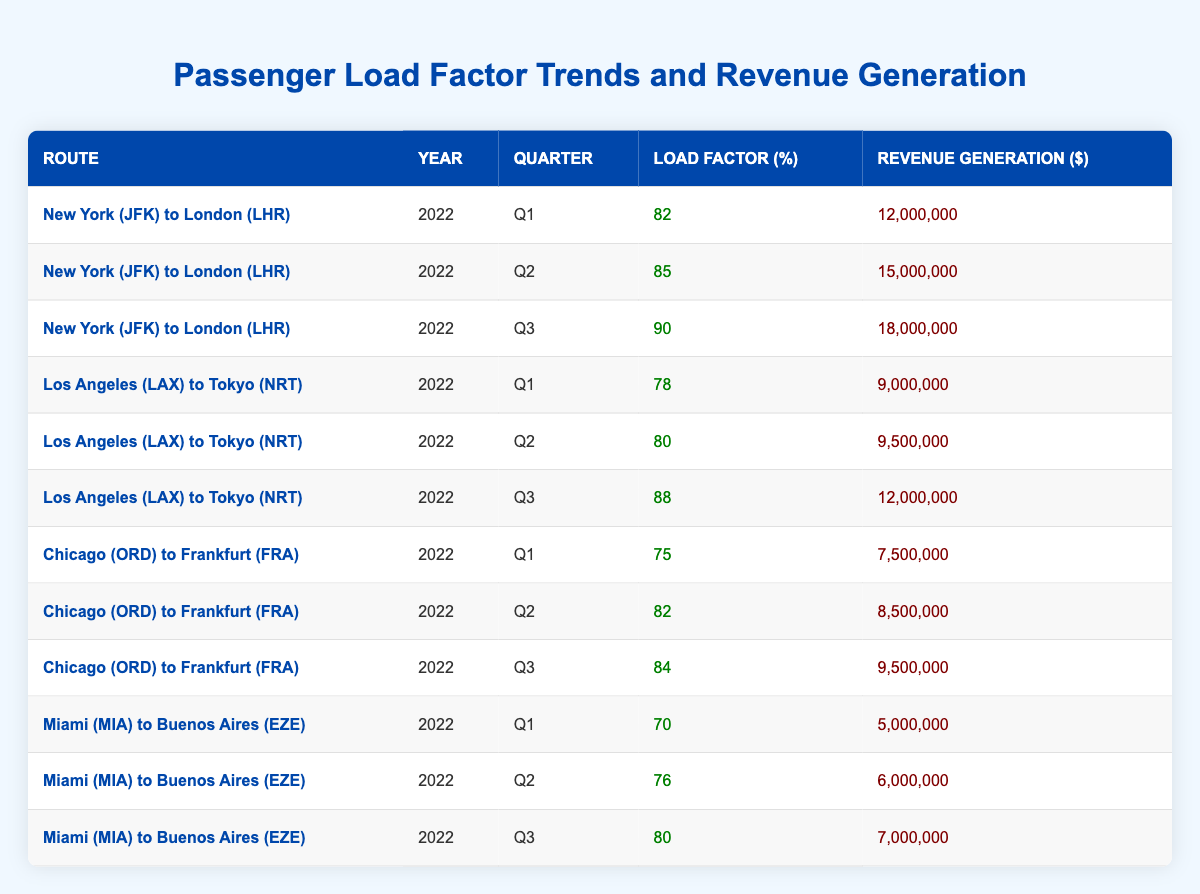What was the highest load factor recorded for the route from New York (JFK) to London (LHR)? The load factors for the New York (JFK) to London (LHR) route in 2022 are 82, 85, and 90 for Q1, Q2, and Q3 respectively. The highest among these is 90 in Q3.
Answer: 90 What is the total revenue generated by the route from Miami (MIA) to Buenos Aires (EZE) across all quarters? The revenue generated for the Miami (MIA) to Buenos Aires (EZE) route in Q1, Q2, and Q3 are 5,000,000, 6,000,000, and 7,000,000 respectively. Adding these together gives 5,000,000 + 6,000,000 + 7,000,000 = 18,000,000.
Answer: 18,000,000 Was the load factor for the Los Angeles (LAX) to Tokyo (NRT) route higher in Q3 compared to Q2? The load factors for the Los Angeles (LAX) to Tokyo (NRT) route are 80 in Q2 and 88 in Q3. Since 88 is greater than 80, the statement is true.
Answer: Yes What is the average load factor for all routes in Q2? The load factors in Q2 are 85 (JFK to LHR), 80 (LAX to NRT), 82 (ORD to FRA), and 76 (MIA to EZE). To find the average, we sum these values: 85 + 80 + 82 + 76 = 323, and divide by 4 (the number of routes), resulting in 323 / 4 = 80.75.
Answer: 80.75 Did the Chicago (ORD) to Frankfurt (FRA) route have a consistent increase in revenue over the three quarters? The revenues are 7,500,000 (Q1), 8,500,000 (Q2), and 9,500,000 (Q3). Since each value increases from one quarter to the next, there is a consistent increase in revenue over all three quarters.
Answer: Yes What is the difference in revenue generation between Q3 of New York (JFK) to London (LHR) and Q3 of Los Angeles (LAX) to Tokyo (NRT)? The revenue for New York (JFK) to London (LHR) in Q3 is 18,000,000 and for Los Angeles (LAX) to Tokyo (NRT) it is 12,000,000. The difference is calculated as 18,000,000 - 12,000,000 = 6,000,000.
Answer: 6,000,000 Which route experienced the lowest load factor in Q1? The Q1 load factors for the routes are 82 (JFK to LHR), 78 (LAX to NRT), 75 (ORD to FRA), and 70 (MIA to EZE). The lowest value is 70 for the Miami (MIA) to Buenos Aires (EZE) route.
Answer: Miami (MIA) to Buenos Aires (EZE) What was the total revenue from all routes in Q1 combined? The revenues from Q1 are 12,000,000 (JFK to LHR), 9,000,000 (LAX to NRT), 7,500,000 (ORD to FRA), and 5,000,000 (MIA to EZE). Adding these gives 12,000,000 + 9,000,000 + 7,500,000 + 5,000,000 = 33,500,000.
Answer: 33,500,000 What is the median load factor for the Chicago (ORD) to Frankfurt (FRA) route? The load factors for Chicago (ORD) to Frankfurt (FRA) are 75, 82, and 84. When arranged in order, they are 75, 82, and 84. The median is the middle value, which is 82.
Answer: 82 